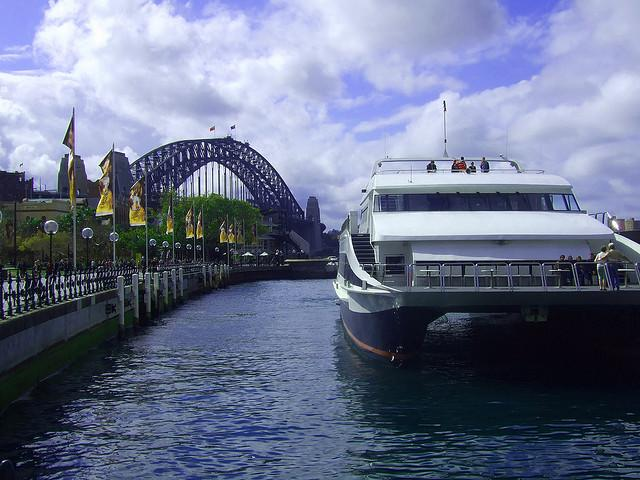Why the gap underneath the boat? Please explain your reasoning. stability. The gap helps provide stability. 